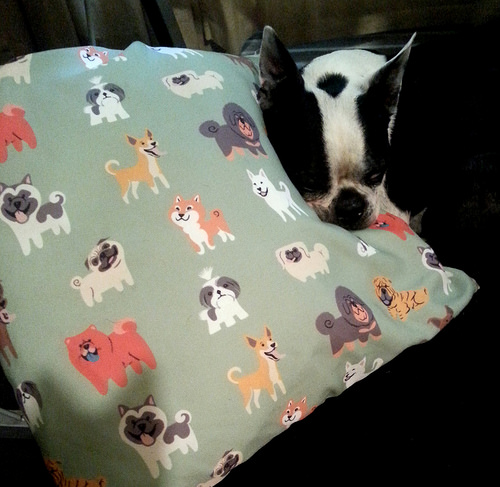<image>
Is the brown dog behind the white dog? No. The brown dog is not behind the white dog. From this viewpoint, the brown dog appears to be positioned elsewhere in the scene. 